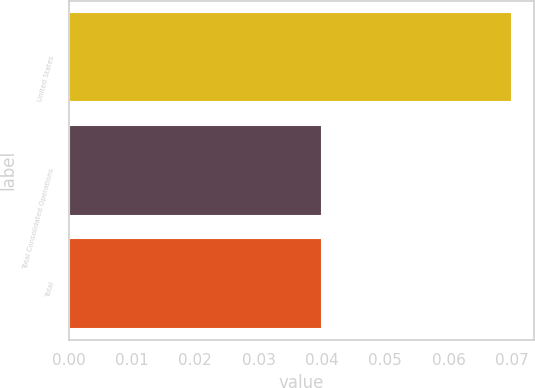<chart> <loc_0><loc_0><loc_500><loc_500><bar_chart><fcel>United States<fcel>Total Consolidated Operations<fcel>Total<nl><fcel>0.07<fcel>0.04<fcel>0.04<nl></chart> 